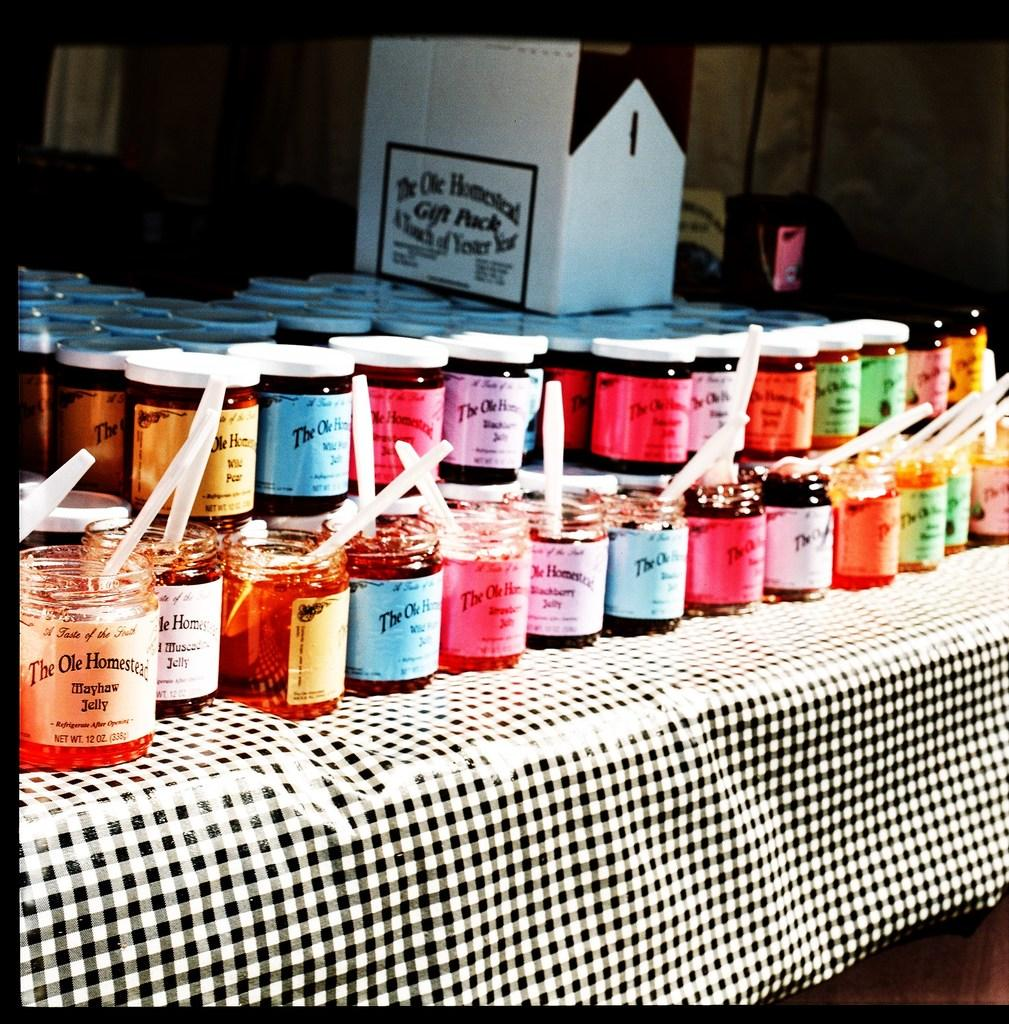Provide a one-sentence caption for the provided image. A table with several different flavored Jams with a box in the back reading "The Ole Homestead". 